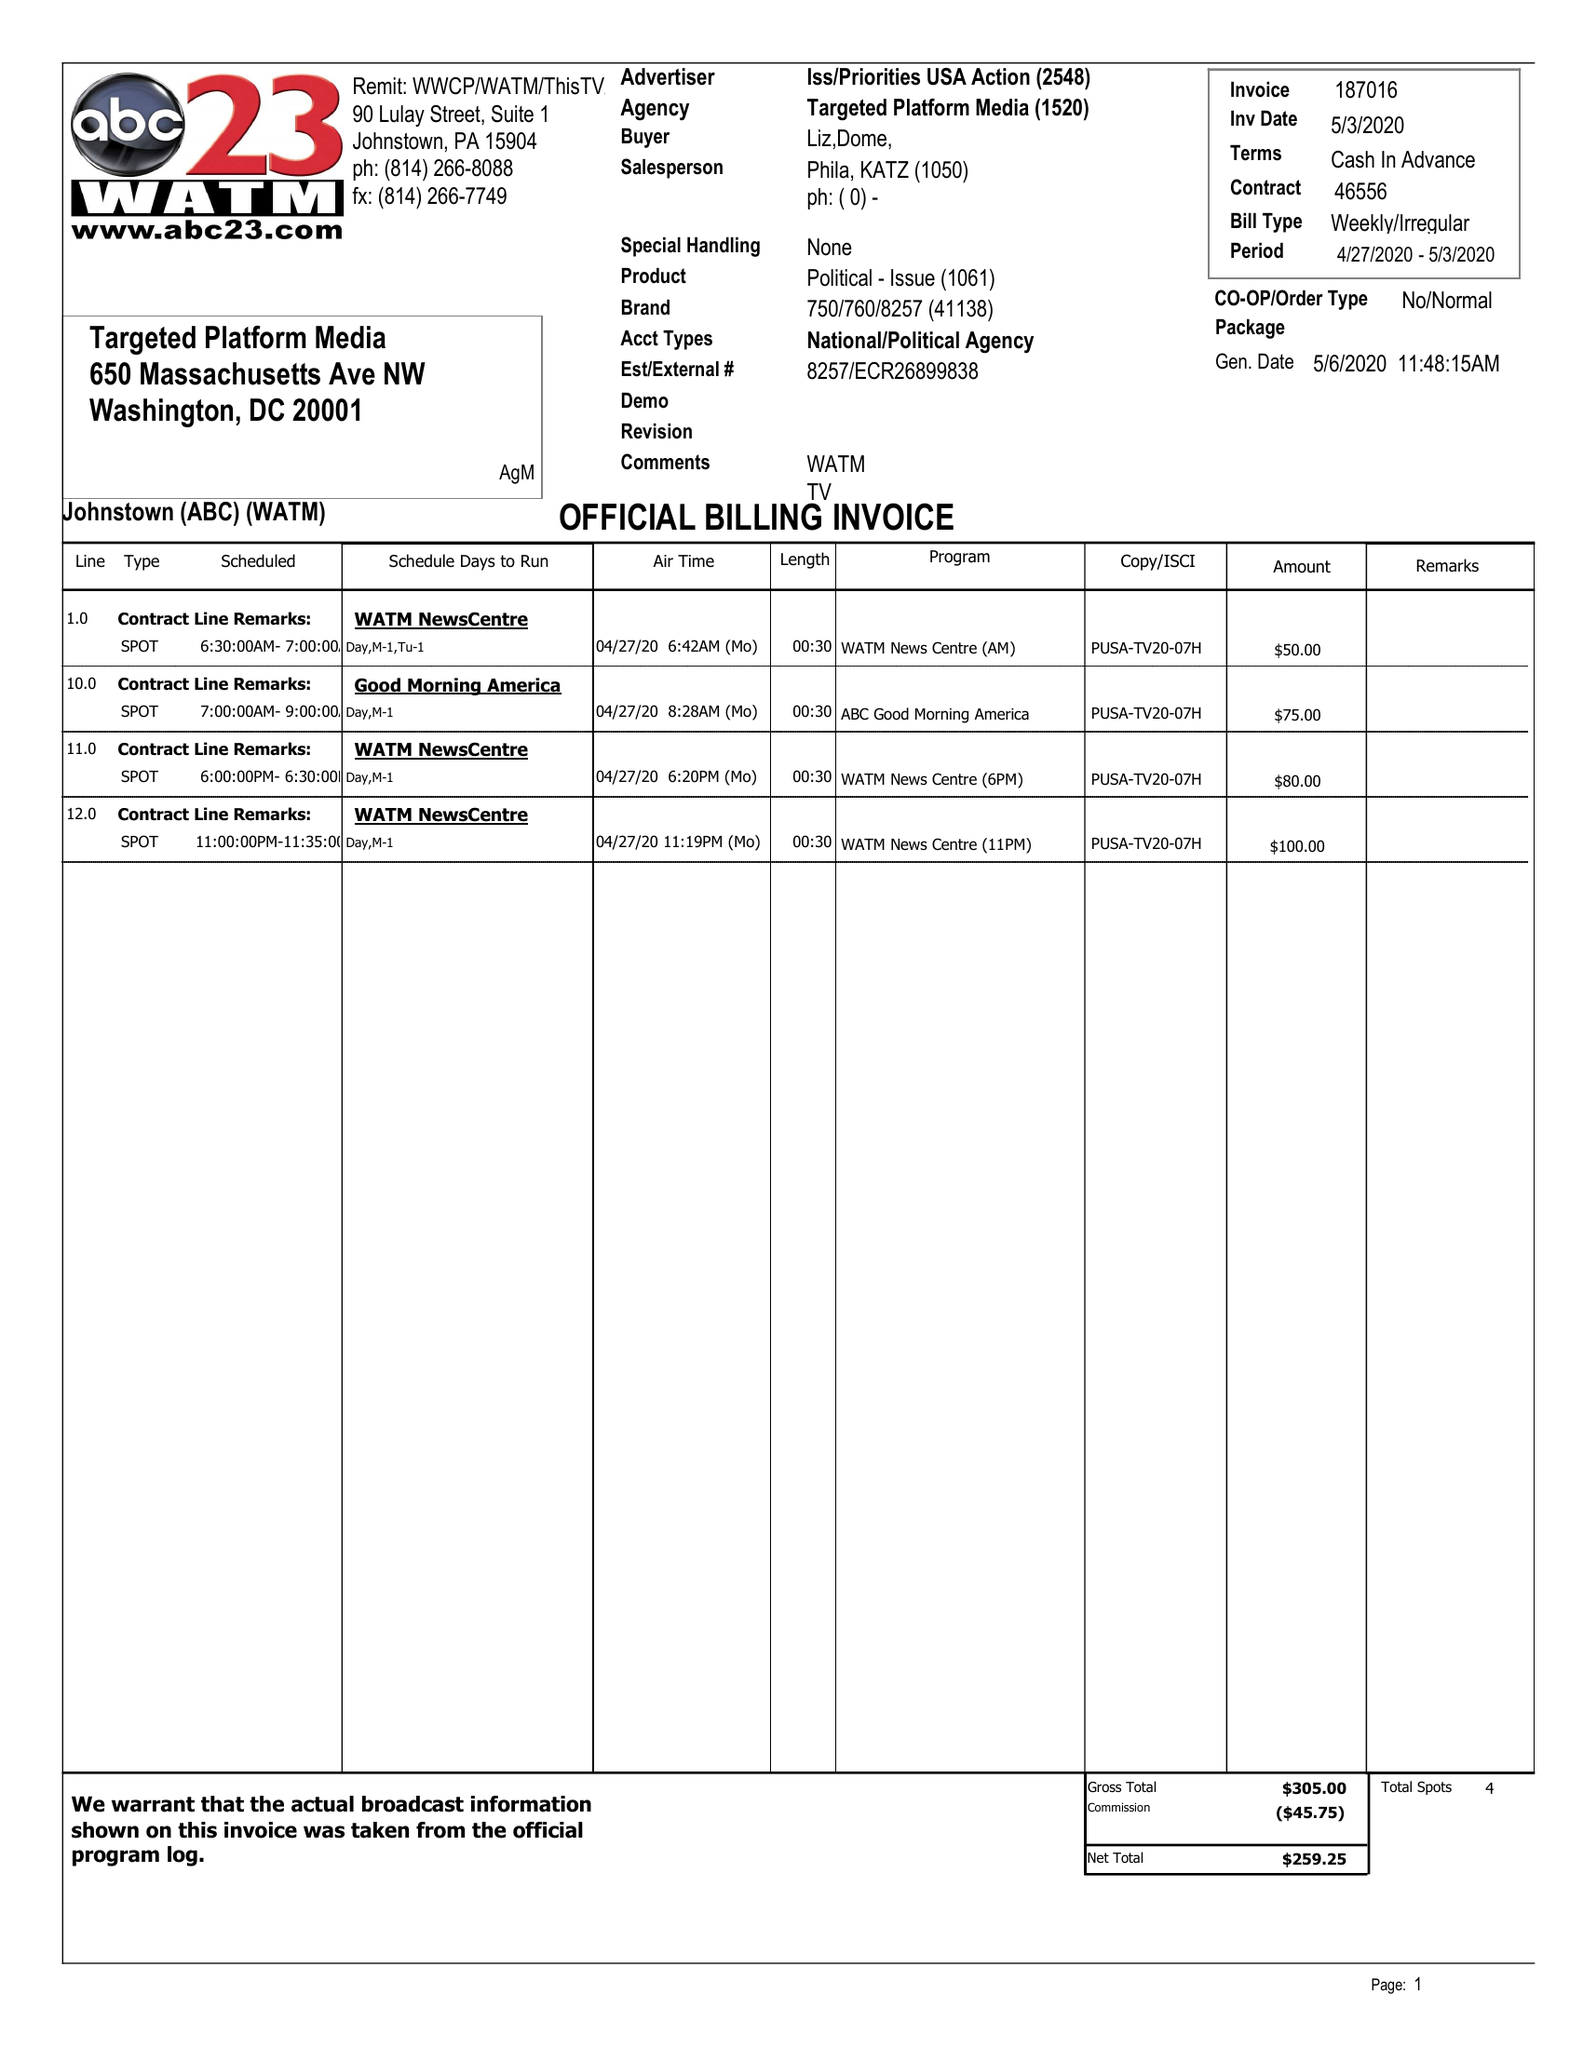What is the value for the flight_from?
Answer the question using a single word or phrase. 04/27/20 